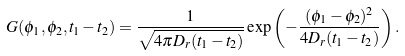<formula> <loc_0><loc_0><loc_500><loc_500>G ( \phi _ { 1 } , \phi _ { 2 } , t _ { 1 } - t _ { 2 } ) = \frac { 1 } { \sqrt { 4 \pi D _ { r } ( t _ { 1 } - t _ { 2 } ) } } \exp \left ( { - \frac { ( \phi _ { 1 } - \phi _ { 2 } ) ^ { 2 } } { 4 D _ { r } ( t _ { 1 } - t _ { 2 } ) } } \right ) .</formula> 